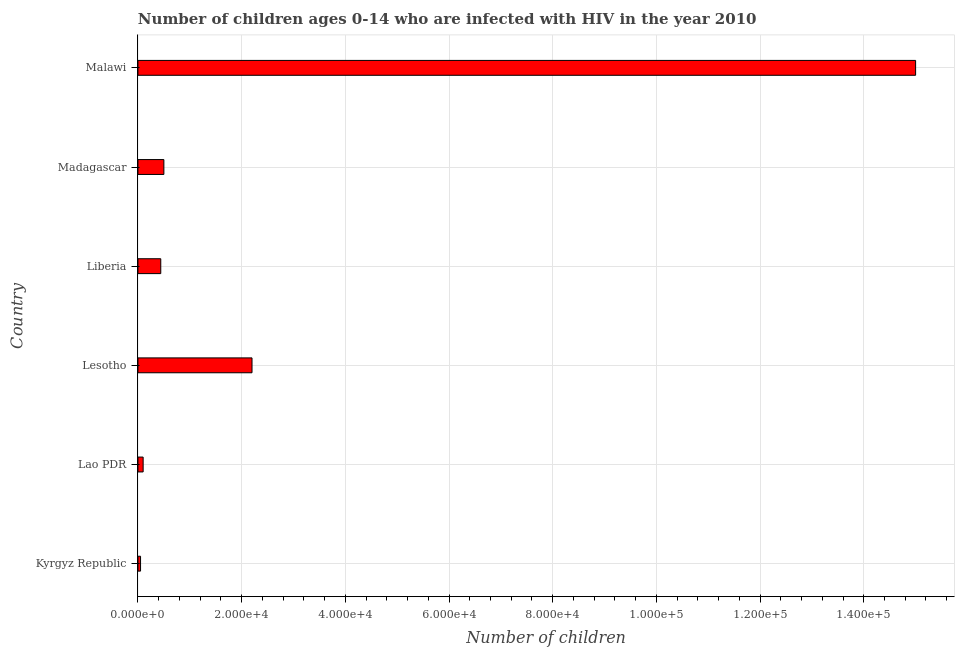Does the graph contain grids?
Provide a short and direct response. Yes. What is the title of the graph?
Provide a succinct answer. Number of children ages 0-14 who are infected with HIV in the year 2010. What is the label or title of the X-axis?
Offer a very short reply. Number of children. What is the number of children living with hiv in Liberia?
Your response must be concise. 4400. In which country was the number of children living with hiv maximum?
Provide a succinct answer. Malawi. In which country was the number of children living with hiv minimum?
Your answer should be very brief. Kyrgyz Republic. What is the sum of the number of children living with hiv?
Your answer should be compact. 1.83e+05. What is the difference between the number of children living with hiv in Kyrgyz Republic and Madagascar?
Your answer should be very brief. -4500. What is the average number of children living with hiv per country?
Your answer should be very brief. 3.05e+04. What is the median number of children living with hiv?
Keep it short and to the point. 4700. In how many countries, is the number of children living with hiv greater than 84000 ?
Provide a succinct answer. 1. Is the number of children living with hiv in Liberia less than that in Madagascar?
Ensure brevity in your answer.  Yes. Is the difference between the number of children living with hiv in Kyrgyz Republic and Malawi greater than the difference between any two countries?
Your answer should be compact. Yes. What is the difference between the highest and the second highest number of children living with hiv?
Offer a very short reply. 1.28e+05. What is the difference between the highest and the lowest number of children living with hiv?
Make the answer very short. 1.50e+05. In how many countries, is the number of children living with hiv greater than the average number of children living with hiv taken over all countries?
Your answer should be compact. 1. How many bars are there?
Your answer should be compact. 6. Are all the bars in the graph horizontal?
Give a very brief answer. Yes. How many countries are there in the graph?
Provide a succinct answer. 6. Are the values on the major ticks of X-axis written in scientific E-notation?
Ensure brevity in your answer.  Yes. What is the Number of children of Kyrgyz Republic?
Make the answer very short. 500. What is the Number of children of Lao PDR?
Your answer should be compact. 1000. What is the Number of children of Lesotho?
Keep it short and to the point. 2.20e+04. What is the Number of children in Liberia?
Keep it short and to the point. 4400. What is the Number of children of Madagascar?
Your answer should be very brief. 5000. What is the Number of children of Malawi?
Offer a terse response. 1.50e+05. What is the difference between the Number of children in Kyrgyz Republic and Lao PDR?
Offer a terse response. -500. What is the difference between the Number of children in Kyrgyz Republic and Lesotho?
Your answer should be very brief. -2.15e+04. What is the difference between the Number of children in Kyrgyz Republic and Liberia?
Your response must be concise. -3900. What is the difference between the Number of children in Kyrgyz Republic and Madagascar?
Your response must be concise. -4500. What is the difference between the Number of children in Kyrgyz Republic and Malawi?
Your answer should be compact. -1.50e+05. What is the difference between the Number of children in Lao PDR and Lesotho?
Offer a terse response. -2.10e+04. What is the difference between the Number of children in Lao PDR and Liberia?
Your response must be concise. -3400. What is the difference between the Number of children in Lao PDR and Madagascar?
Your answer should be compact. -4000. What is the difference between the Number of children in Lao PDR and Malawi?
Your answer should be very brief. -1.49e+05. What is the difference between the Number of children in Lesotho and Liberia?
Your answer should be compact. 1.76e+04. What is the difference between the Number of children in Lesotho and Madagascar?
Your answer should be compact. 1.70e+04. What is the difference between the Number of children in Lesotho and Malawi?
Provide a succinct answer. -1.28e+05. What is the difference between the Number of children in Liberia and Madagascar?
Keep it short and to the point. -600. What is the difference between the Number of children in Liberia and Malawi?
Your answer should be compact. -1.46e+05. What is the difference between the Number of children in Madagascar and Malawi?
Provide a succinct answer. -1.45e+05. What is the ratio of the Number of children in Kyrgyz Republic to that in Lao PDR?
Offer a terse response. 0.5. What is the ratio of the Number of children in Kyrgyz Republic to that in Lesotho?
Give a very brief answer. 0.02. What is the ratio of the Number of children in Kyrgyz Republic to that in Liberia?
Make the answer very short. 0.11. What is the ratio of the Number of children in Kyrgyz Republic to that in Madagascar?
Offer a terse response. 0.1. What is the ratio of the Number of children in Kyrgyz Republic to that in Malawi?
Give a very brief answer. 0. What is the ratio of the Number of children in Lao PDR to that in Lesotho?
Your answer should be very brief. 0.04. What is the ratio of the Number of children in Lao PDR to that in Liberia?
Provide a short and direct response. 0.23. What is the ratio of the Number of children in Lao PDR to that in Madagascar?
Make the answer very short. 0.2. What is the ratio of the Number of children in Lao PDR to that in Malawi?
Offer a terse response. 0.01. What is the ratio of the Number of children in Lesotho to that in Malawi?
Your answer should be compact. 0.15. What is the ratio of the Number of children in Liberia to that in Madagascar?
Offer a very short reply. 0.88. What is the ratio of the Number of children in Liberia to that in Malawi?
Give a very brief answer. 0.03. What is the ratio of the Number of children in Madagascar to that in Malawi?
Provide a succinct answer. 0.03. 